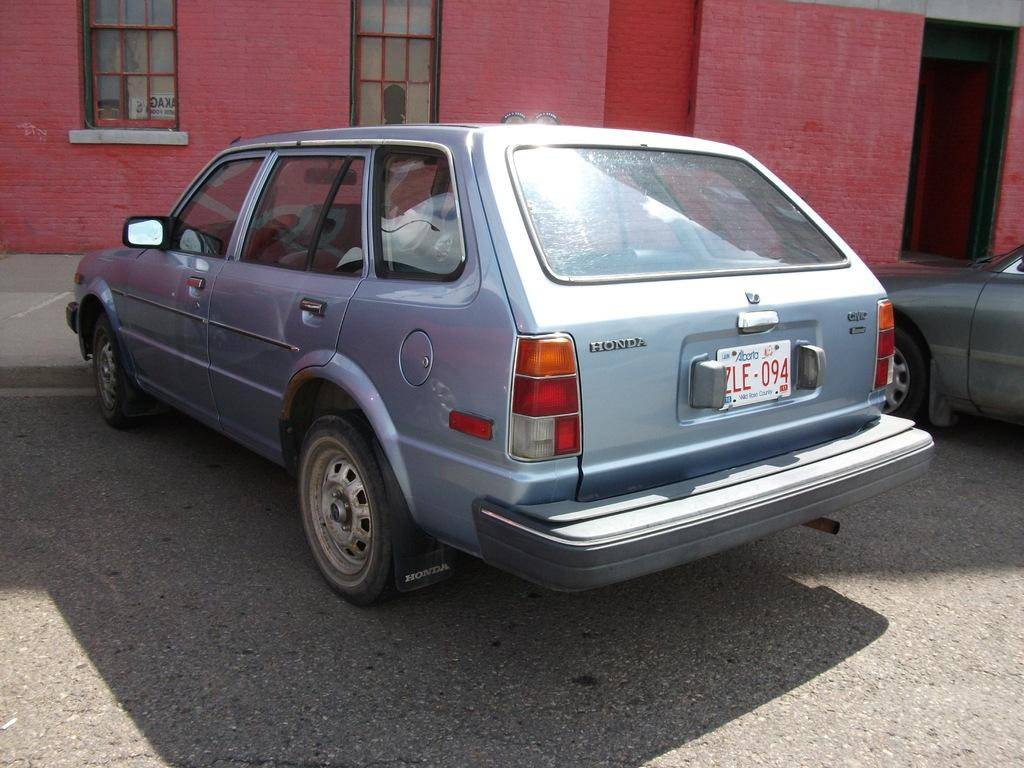What type of structure is present in the image? There is a building in the image. What features can be observed on the building? The building has windows and a door. What else can be seen in the image besides the building? There are vehicles on the road in the image. How does the building bite into the apple in the image? There is no apple present in the image, and buildings do not have the ability to bite. 